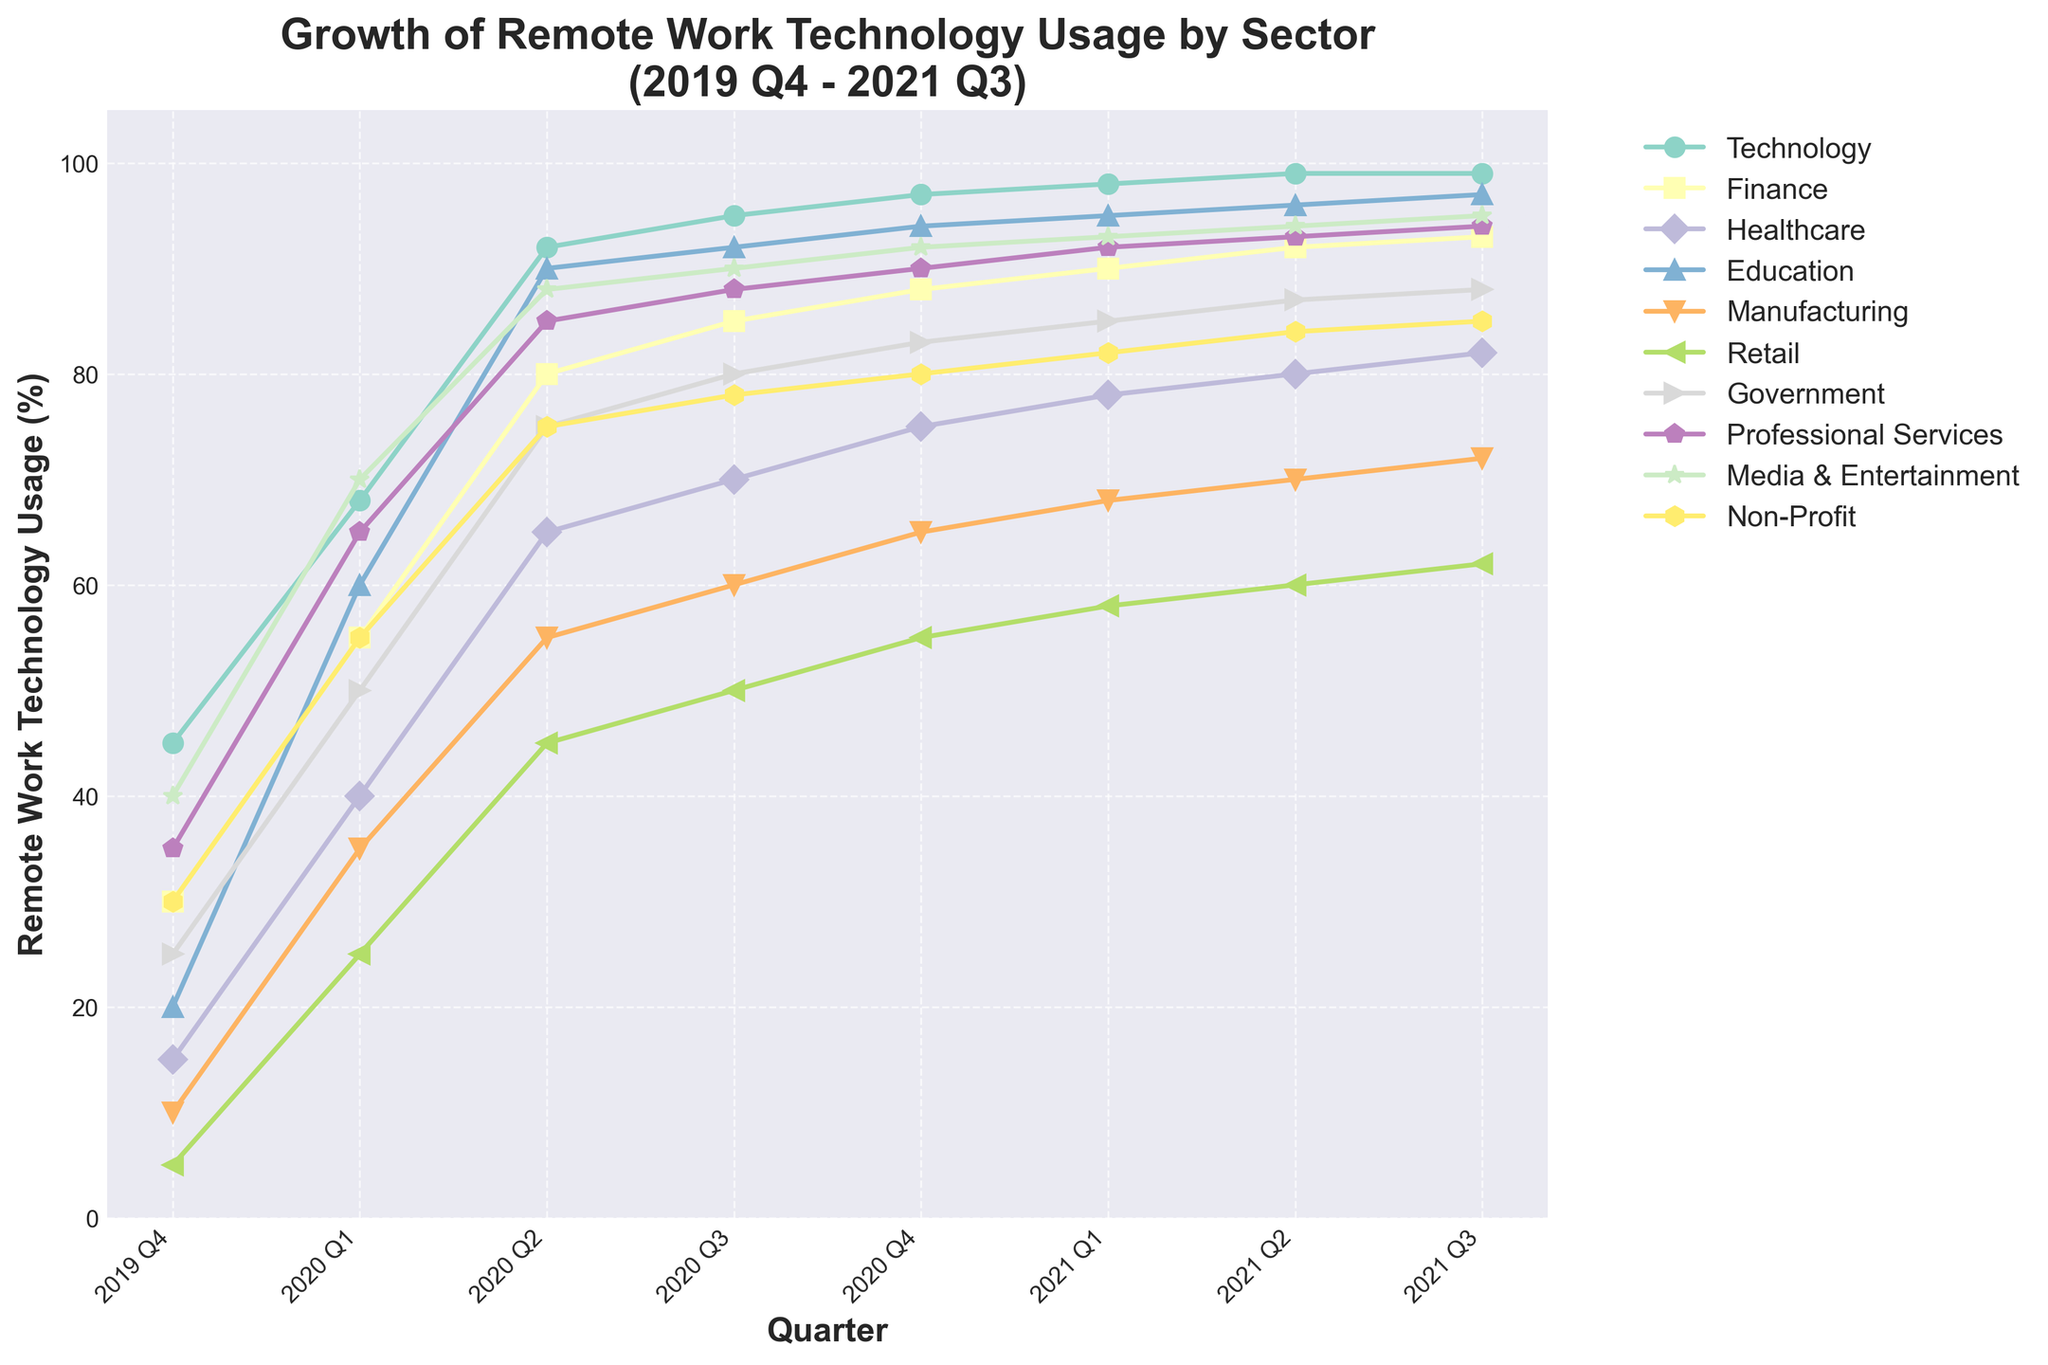What sector shows the highest increase in remote work technology usage from 2019 Q4 to 2021 Q3? To find the sector with the highest increase, subtract the 2019 Q4 value from the 2021 Q3 value for each sector. The Education sector increases from 20% to 97%, which is a 77% increase.
Answer: Education Which two sectors have nearly equal remote work technology usage in 2020 Q4? Compare the values of remote work technology usage in 2020 Q4 for all sectors. Professional Services and Media & Entertainment both have 92%, and they are nearly equal to the Education sector at 94%.
Answer: Professional Services and Media & Entertainment What is the average remote work technology usage across all sectors in 2020 Q2? Add the usage percentages of all sectors in 2020 Q2 and divide by the number of sectors: (92 + 80 + 65 + 90 + 55 + 45 + 75 + 85 + 88 + 75) / 10 = 75.
Answer: 75 Which sector had the lowest percentage increase in remote work technology usage from 2019 Q4 to 2021 Q3? Calculate the increase for each sector from 2019 Q4 to 2021 Q3. Retail increases from 5% to 62%, which is a 57% increase, the lowest compared to the other sectors.
Answer: Retail Between which consecutive quarters did the Technology sector see its largest increase in remote work technology usage? By comparing the differences between each consecutive quarter for the Technology sector: From 2020 Q1 (68%) to 2020 Q2 (92%), the increase is 24%, which is the largest.
Answer: 2020 Q1 to 2020 Q2 How many sectors had a remote work technology usage of at least 90% by 2021 Q3? Count the sectors with usage percentages equal to or greater than 90% in 2021 Q3: Technology (99%), Finance (93%), Education (97%), Professional Services (94%), Media & Entertainment (95%).
Answer: 5 Which sector shows a linear-like increase in remote work technology usage over the given period? Check the visual trend for each sector to see which follows a roughly straight-line pattern. The Finance sector shows a consistent steady increase from 30% in 2019 Q4 to 93% in 2021 Q3.
Answer: Finance What was the relative increase in remote work technology usage for the Healthcare sector from 2020 Q3 to 2021 Q3? Subtract the 2020 Q3 value from the 2021 Q3 value for the Healthcare sector (82% - 70% = 12%). The relative increase is 12%.
Answer: 12% How does the growth trend of the Government sector compare to that of the Manufacturing sector between 2020 Q1 and 2020 Q4? The Government sector grows from 50% to 83% (a 33% increase), while Manufacturing increases from 35% to 65% (a 30% increase). The Government sector has a higher increase.
Answer: The Government sector has a higher increase than the Manufacturing sector What is the total increase in remote work technology usage across all sectors from 2019 Q4 to 2021 Q3? Calculate the increase for each sector and sum them up: Technology (54), Finance (63), Healthcare (67), Education (77), Manufacturing (62), Retail (57), Government (63), Professional Services (59), Media & Entertainment (55), Non-Profit (55). The total increase is 562%.
Answer: 562% 